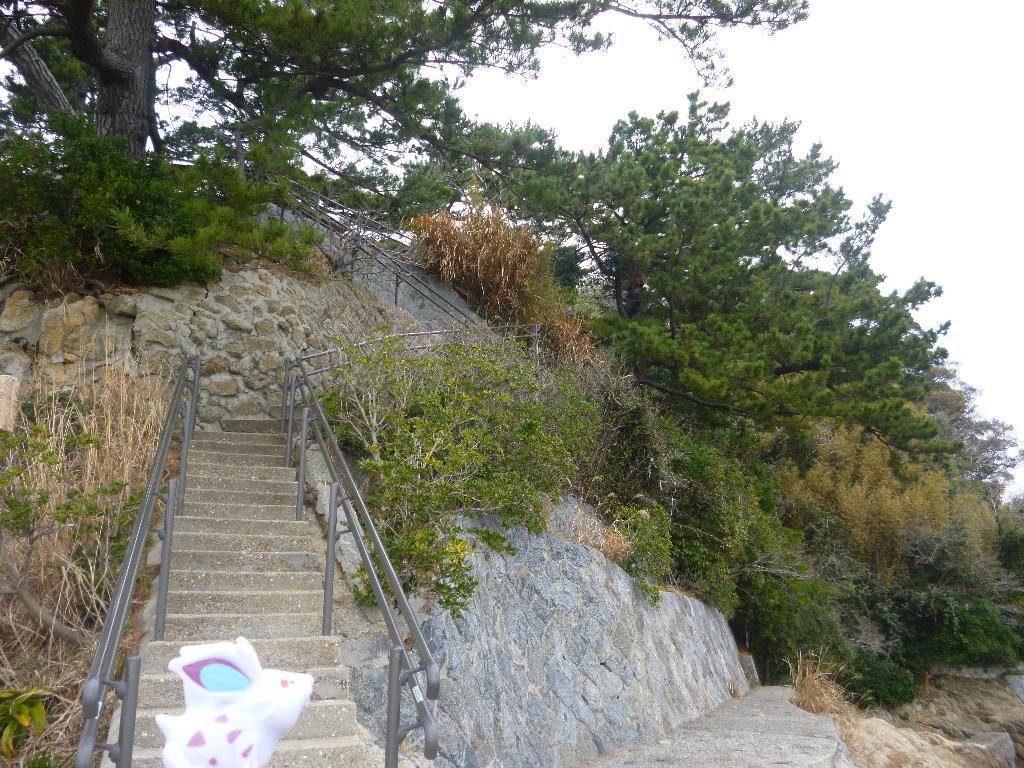Can you describe this image briefly? In this image there are steps in the middle. At the top there is a tree with the green leaves. On the right side there are so many there are so many trees on the rock. At the top there is the sky. There are railings on either side of the steps. 